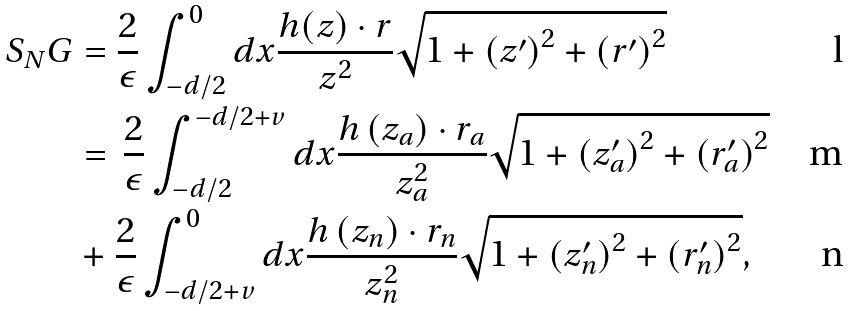Convert formula to latex. <formula><loc_0><loc_0><loc_500><loc_500>S _ { N } G & = \frac { 2 } { \epsilon } \int _ { - d / 2 } ^ { 0 } d x \frac { h ( z ) \cdot r } { z ^ { 2 } } \sqrt { 1 + \left ( z ^ { \prime } \right ) ^ { 2 } + \left ( r ^ { \prime } \right ) ^ { 2 } } \\ & = \, \frac { 2 } { \epsilon } \int _ { - d / 2 } ^ { - d / 2 + v } d x \frac { h \left ( z _ { a } \right ) \cdot r _ { a } } { z _ { a } ^ { 2 } } \sqrt { 1 + \left ( z _ { a } ^ { \prime } \right ) ^ { 2 } + \left ( r _ { a } ^ { \prime } \right ) ^ { 2 } } \\ & + \frac { 2 } { \epsilon } \int _ { - d / 2 + v } ^ { 0 } d x \frac { h \left ( z _ { n } \right ) \cdot r _ { n } } { z _ { n } ^ { 2 } } \sqrt { 1 + \left ( z _ { n } ^ { \prime } \right ) ^ { 2 } + \left ( r _ { n } ^ { \prime } \right ) ^ { 2 } } ,</formula> 